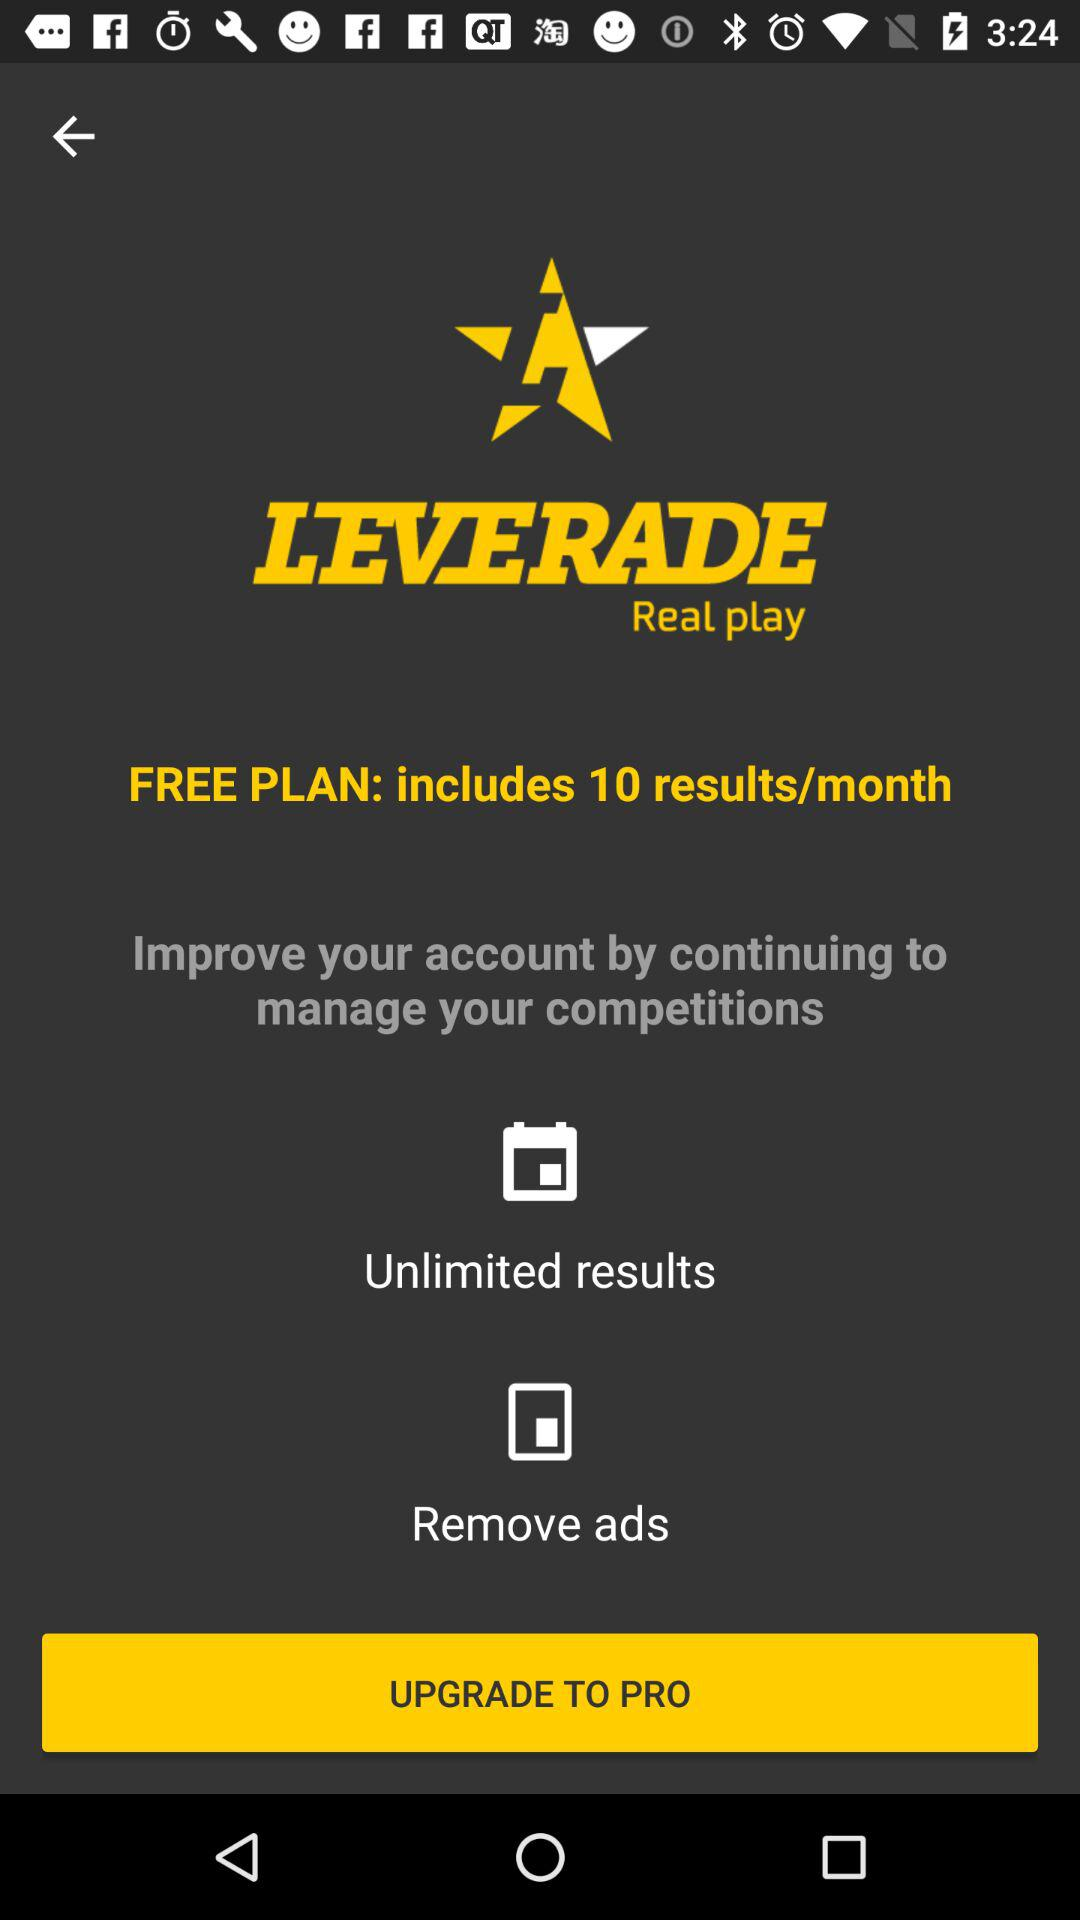Which version is given for update?
When the provided information is insufficient, respond with <no answer>. <no answer> 